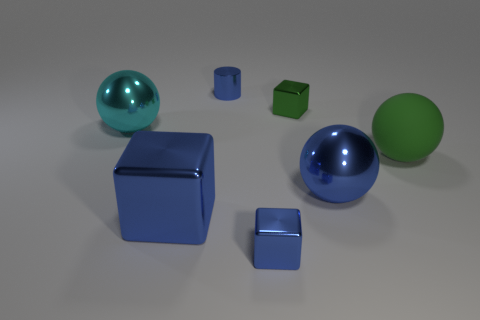Subtract all blue spheres. How many spheres are left? 2 Add 1 gray metallic cubes. How many objects exist? 8 Subtract all yellow cylinders. How many blue cubes are left? 2 Subtract 2 balls. How many balls are left? 1 Subtract all green cubes. How many cubes are left? 2 Add 2 large gray balls. How many large gray balls exist? 2 Subtract 1 green cubes. How many objects are left? 6 Subtract all cylinders. How many objects are left? 6 Subtract all green cylinders. Subtract all blue cubes. How many cylinders are left? 1 Subtract all large blue balls. Subtract all green spheres. How many objects are left? 5 